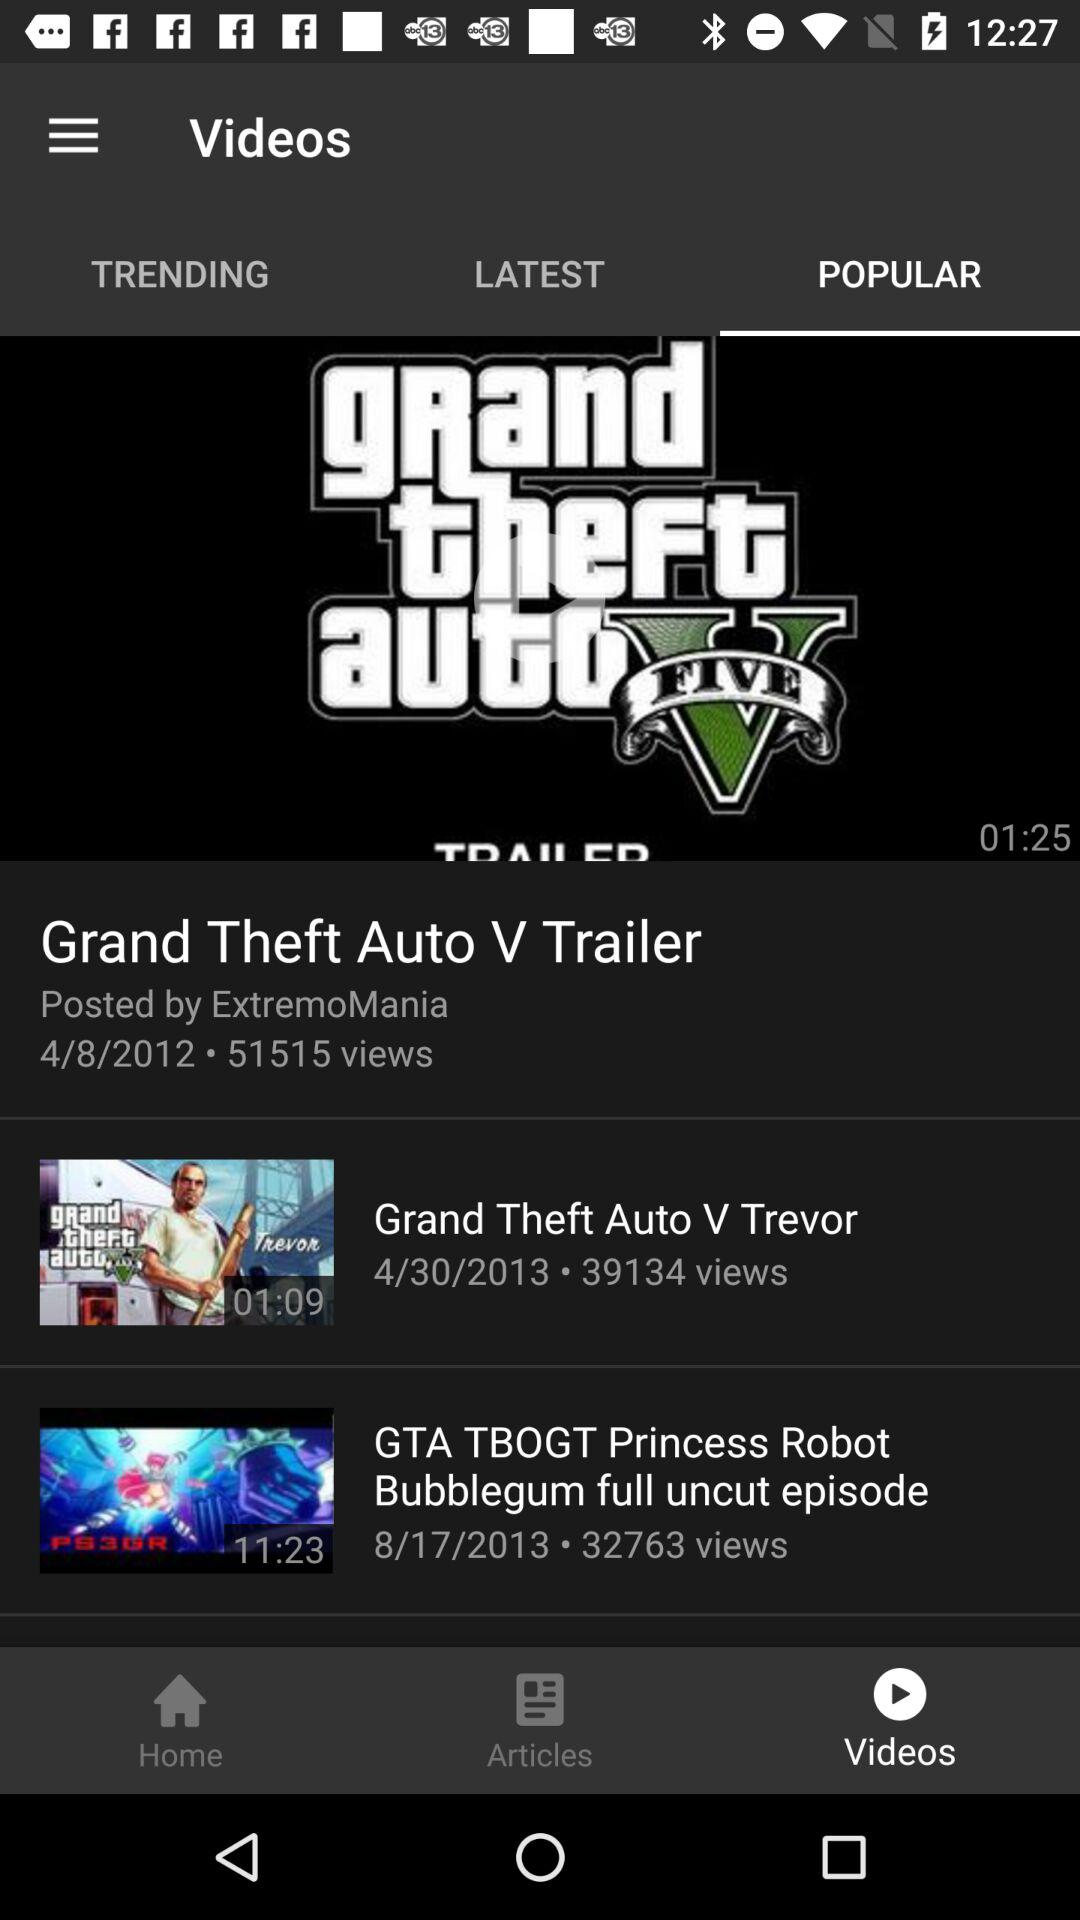By whom was the video "Grand Theft Auto V Trailer" posted? The video "Grand Theft Auto V Trailer" was posted by "ExtremoMania". 